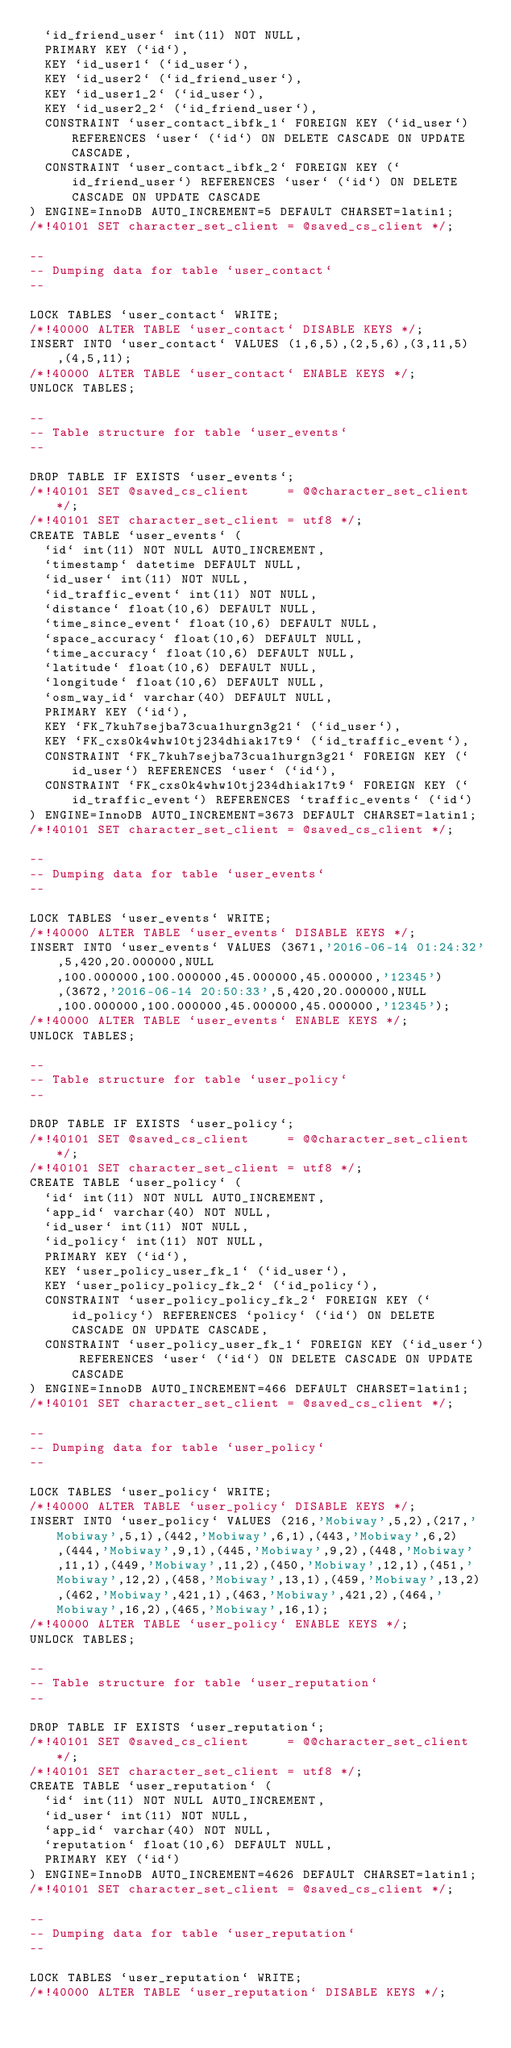<code> <loc_0><loc_0><loc_500><loc_500><_SQL_>  `id_friend_user` int(11) NOT NULL,
  PRIMARY KEY (`id`),
  KEY `id_user1` (`id_user`),
  KEY `id_user2` (`id_friend_user`),
  KEY `id_user1_2` (`id_user`),
  KEY `id_user2_2` (`id_friend_user`),
  CONSTRAINT `user_contact_ibfk_1` FOREIGN KEY (`id_user`) REFERENCES `user` (`id`) ON DELETE CASCADE ON UPDATE CASCADE,
  CONSTRAINT `user_contact_ibfk_2` FOREIGN KEY (`id_friend_user`) REFERENCES `user` (`id`) ON DELETE CASCADE ON UPDATE CASCADE
) ENGINE=InnoDB AUTO_INCREMENT=5 DEFAULT CHARSET=latin1;
/*!40101 SET character_set_client = @saved_cs_client */;

--
-- Dumping data for table `user_contact`
--

LOCK TABLES `user_contact` WRITE;
/*!40000 ALTER TABLE `user_contact` DISABLE KEYS */;
INSERT INTO `user_contact` VALUES (1,6,5),(2,5,6),(3,11,5),(4,5,11);
/*!40000 ALTER TABLE `user_contact` ENABLE KEYS */;
UNLOCK TABLES;

--
-- Table structure for table `user_events`
--

DROP TABLE IF EXISTS `user_events`;
/*!40101 SET @saved_cs_client     = @@character_set_client */;
/*!40101 SET character_set_client = utf8 */;
CREATE TABLE `user_events` (
  `id` int(11) NOT NULL AUTO_INCREMENT,
  `timestamp` datetime DEFAULT NULL,
  `id_user` int(11) NOT NULL,
  `id_traffic_event` int(11) NOT NULL,
  `distance` float(10,6) DEFAULT NULL,
  `time_since_event` float(10,6) DEFAULT NULL,
  `space_accuracy` float(10,6) DEFAULT NULL,
  `time_accuracy` float(10,6) DEFAULT NULL,
  `latitude` float(10,6) DEFAULT NULL,
  `longitude` float(10,6) DEFAULT NULL,
  `osm_way_id` varchar(40) DEFAULT NULL,
  PRIMARY KEY (`id`),
  KEY `FK_7kuh7sejba73cua1hurgn3g21` (`id_user`),
  KEY `FK_cxs0k4whw10tj234dhiak17t9` (`id_traffic_event`),
  CONSTRAINT `FK_7kuh7sejba73cua1hurgn3g21` FOREIGN KEY (`id_user`) REFERENCES `user` (`id`),
  CONSTRAINT `FK_cxs0k4whw10tj234dhiak17t9` FOREIGN KEY (`id_traffic_event`) REFERENCES `traffic_events` (`id`)
) ENGINE=InnoDB AUTO_INCREMENT=3673 DEFAULT CHARSET=latin1;
/*!40101 SET character_set_client = @saved_cs_client */;

--
-- Dumping data for table `user_events`
--

LOCK TABLES `user_events` WRITE;
/*!40000 ALTER TABLE `user_events` DISABLE KEYS */;
INSERT INTO `user_events` VALUES (3671,'2016-06-14 01:24:32',5,420,20.000000,NULL,100.000000,100.000000,45.000000,45.000000,'12345'),(3672,'2016-06-14 20:50:33',5,420,20.000000,NULL,100.000000,100.000000,45.000000,45.000000,'12345');
/*!40000 ALTER TABLE `user_events` ENABLE KEYS */;
UNLOCK TABLES;

--
-- Table structure for table `user_policy`
--

DROP TABLE IF EXISTS `user_policy`;
/*!40101 SET @saved_cs_client     = @@character_set_client */;
/*!40101 SET character_set_client = utf8 */;
CREATE TABLE `user_policy` (
  `id` int(11) NOT NULL AUTO_INCREMENT,
  `app_id` varchar(40) NOT NULL,
  `id_user` int(11) NOT NULL,
  `id_policy` int(11) NOT NULL,
  PRIMARY KEY (`id`),
  KEY `user_policy_user_fk_1` (`id_user`),
  KEY `user_policy_policy_fk_2` (`id_policy`),
  CONSTRAINT `user_policy_policy_fk_2` FOREIGN KEY (`id_policy`) REFERENCES `policy` (`id`) ON DELETE CASCADE ON UPDATE CASCADE,
  CONSTRAINT `user_policy_user_fk_1` FOREIGN KEY (`id_user`) REFERENCES `user` (`id`) ON DELETE CASCADE ON UPDATE CASCADE
) ENGINE=InnoDB AUTO_INCREMENT=466 DEFAULT CHARSET=latin1;
/*!40101 SET character_set_client = @saved_cs_client */;

--
-- Dumping data for table `user_policy`
--

LOCK TABLES `user_policy` WRITE;
/*!40000 ALTER TABLE `user_policy` DISABLE KEYS */;
INSERT INTO `user_policy` VALUES (216,'Mobiway',5,2),(217,'Mobiway',5,1),(442,'Mobiway',6,1),(443,'Mobiway',6,2),(444,'Mobiway',9,1),(445,'Mobiway',9,2),(448,'Mobiway',11,1),(449,'Mobiway',11,2),(450,'Mobiway',12,1),(451,'Mobiway',12,2),(458,'Mobiway',13,1),(459,'Mobiway',13,2),(462,'Mobiway',421,1),(463,'Mobiway',421,2),(464,'Mobiway',16,2),(465,'Mobiway',16,1);
/*!40000 ALTER TABLE `user_policy` ENABLE KEYS */;
UNLOCK TABLES;

--
-- Table structure for table `user_reputation`
--

DROP TABLE IF EXISTS `user_reputation`;
/*!40101 SET @saved_cs_client     = @@character_set_client */;
/*!40101 SET character_set_client = utf8 */;
CREATE TABLE `user_reputation` (
  `id` int(11) NOT NULL AUTO_INCREMENT,
  `id_user` int(11) NOT NULL,
  `app_id` varchar(40) NOT NULL,
  `reputation` float(10,6) DEFAULT NULL,
  PRIMARY KEY (`id`)
) ENGINE=InnoDB AUTO_INCREMENT=4626 DEFAULT CHARSET=latin1;
/*!40101 SET character_set_client = @saved_cs_client */;

--
-- Dumping data for table `user_reputation`
--

LOCK TABLES `user_reputation` WRITE;
/*!40000 ALTER TABLE `user_reputation` DISABLE KEYS */;</code> 